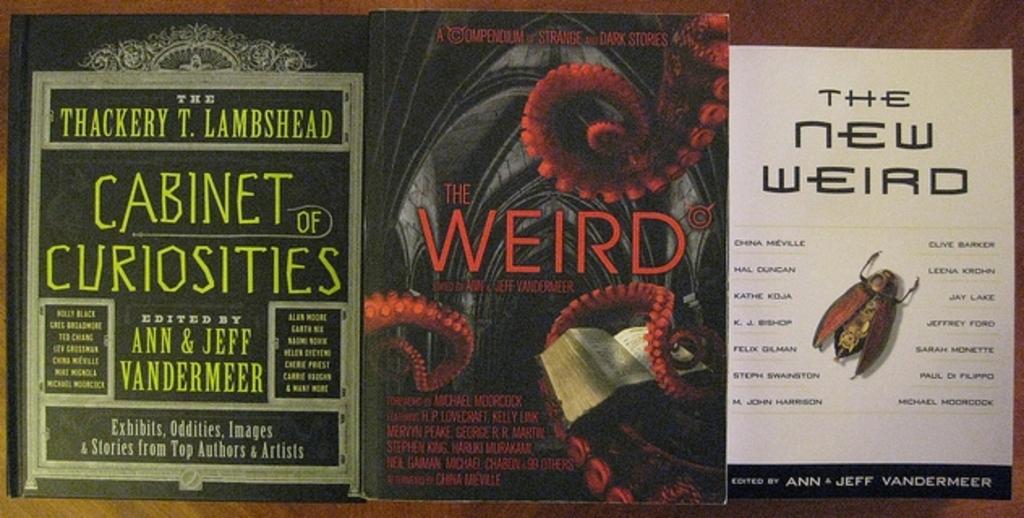Who edited this?
Offer a very short reply. Ann and jeff vandermeer. What is the title of the book with the insect on the cover?
Offer a terse response. The new weird. 